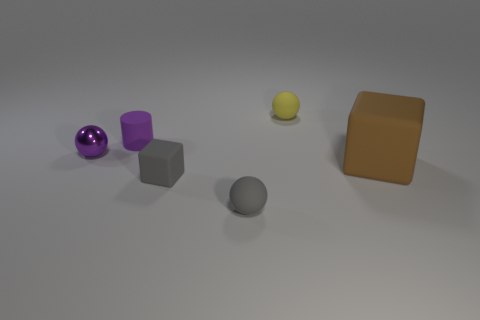Add 4 rubber cylinders. How many objects exist? 10 Subtract all cubes. How many objects are left? 4 Add 5 tiny gray matte balls. How many tiny gray matte balls are left? 6 Add 1 small blue metallic balls. How many small blue metallic balls exist? 1 Subtract 1 gray spheres. How many objects are left? 5 Subtract all small rubber cylinders. Subtract all big blocks. How many objects are left? 4 